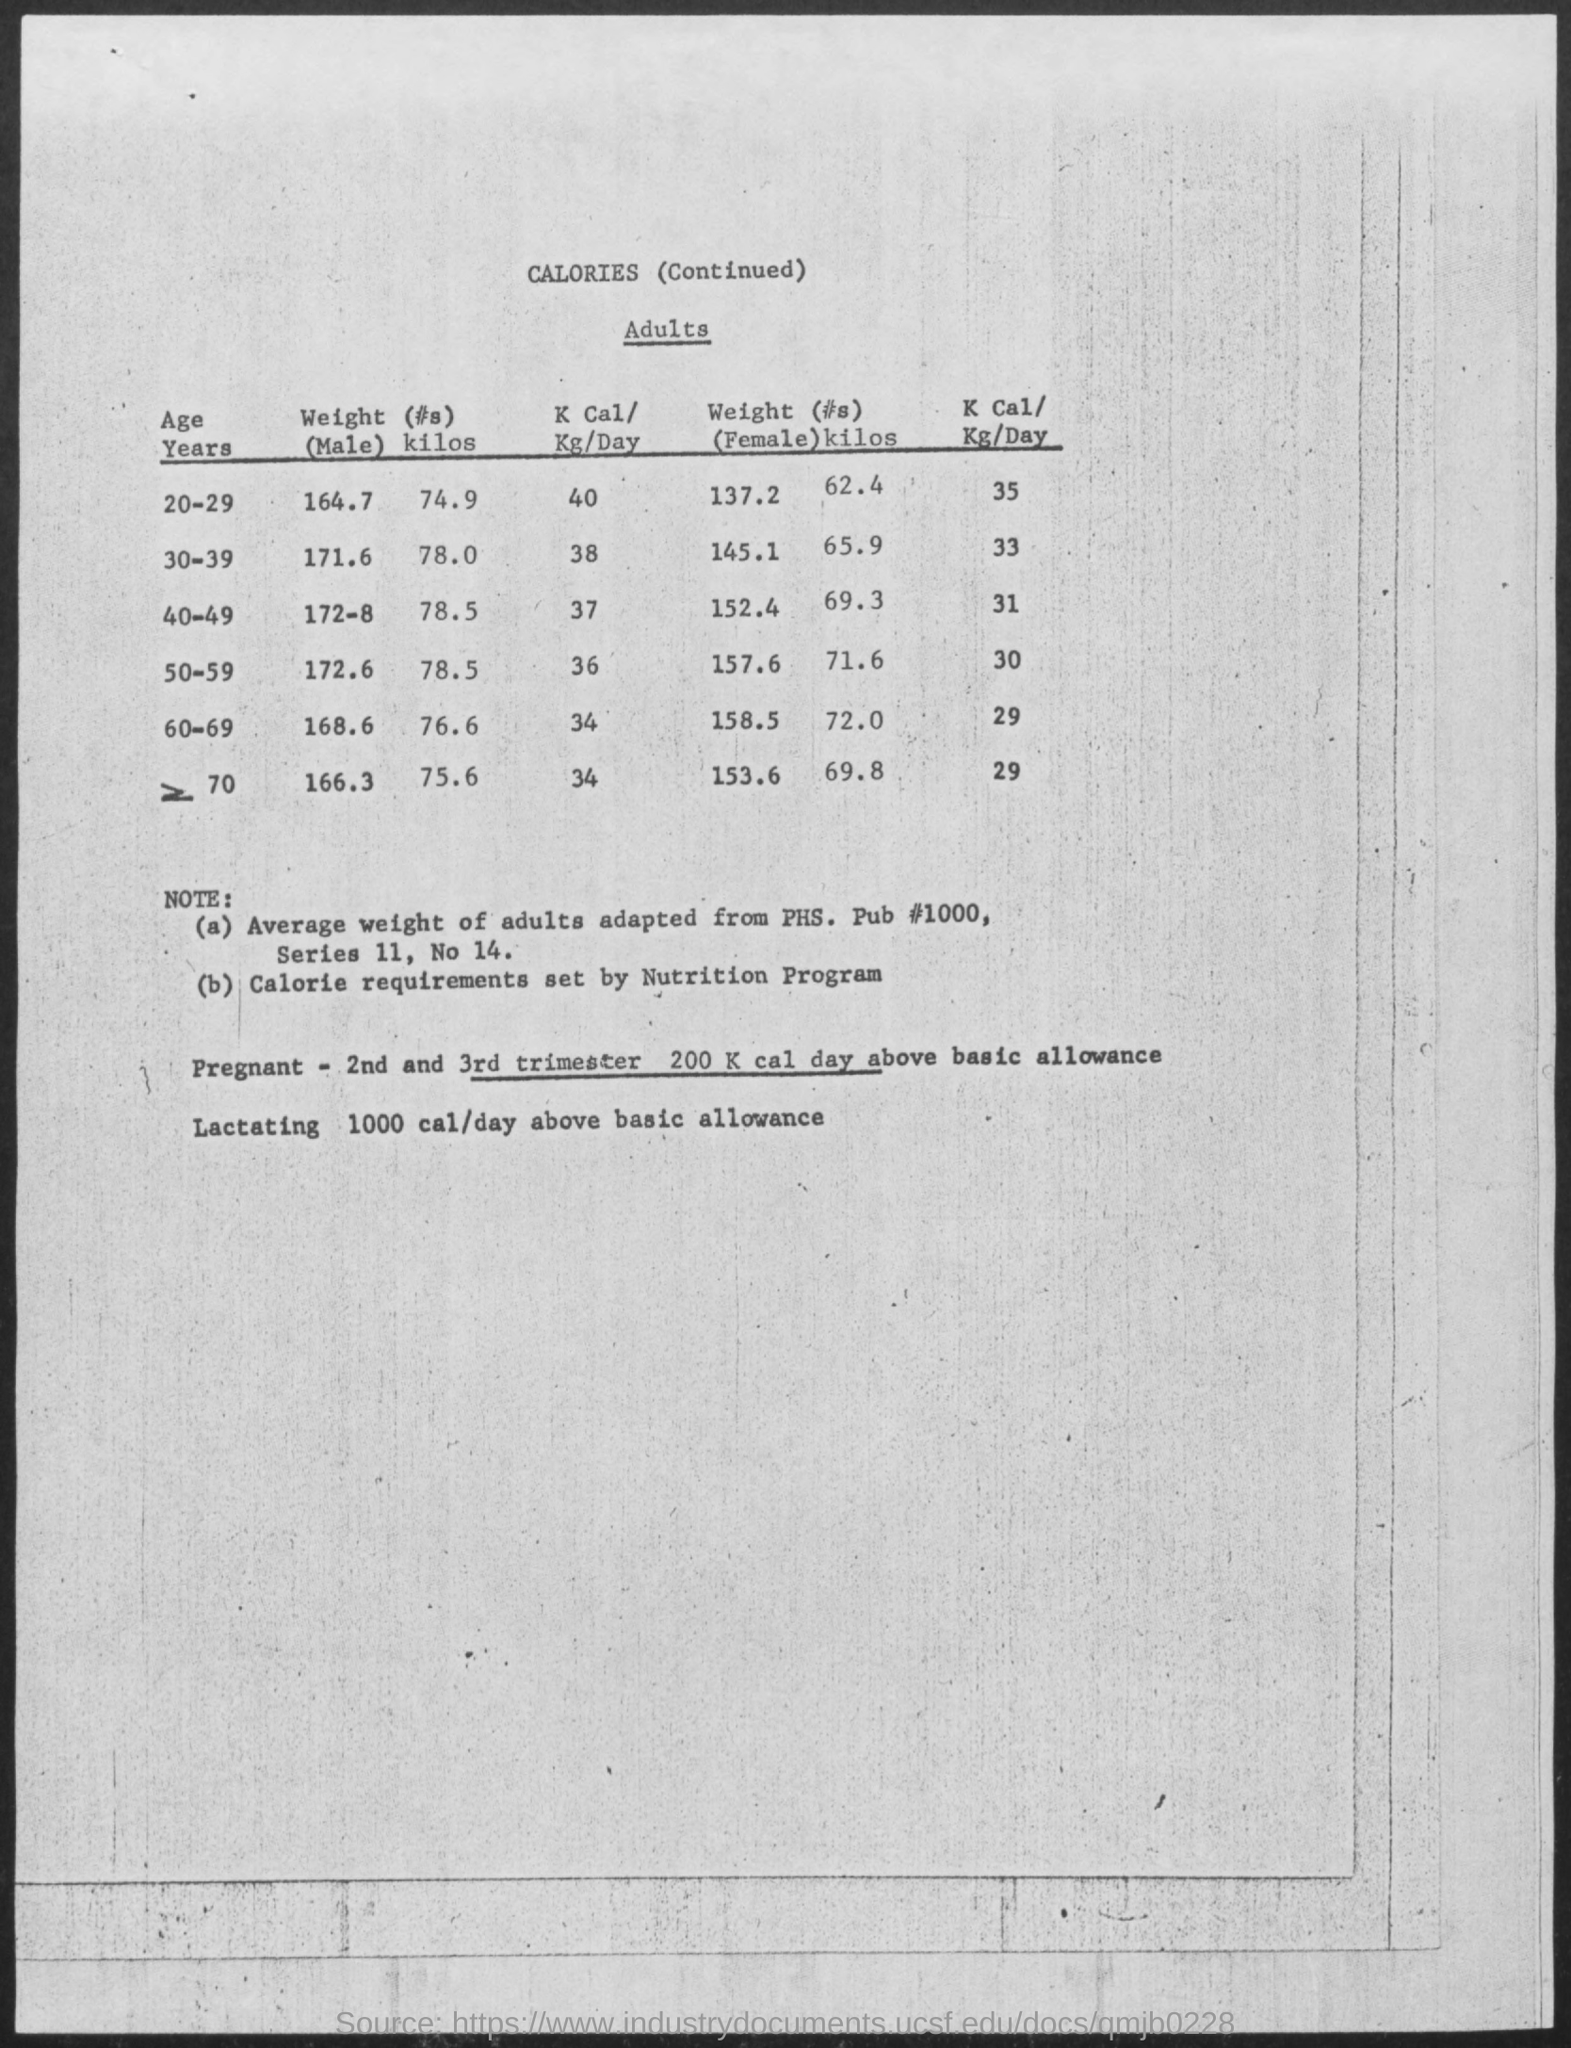What is the Weight for Male of Age 20-29?
Your answer should be very brief. 164.7. What is the Weight for Male of Age 30-39?
Ensure brevity in your answer.  171.6. What is the Weight for Male of Age 40-49?
Your answer should be compact. 172-8. What is the Weight for Male of Age 50-59?
Ensure brevity in your answer.  172.6. What is the Weight for Male of Age 60-69?
Make the answer very short. 168.6. What is the Weight for FeMale of Age 20-29?
Ensure brevity in your answer.  137.2. What is the Weight for FeMale of Age 30-39?
Ensure brevity in your answer.  145.1. What is the Weight for FeMale of Age 40-49?
Provide a short and direct response. 152.4. What is the Weight for FeMale of Age 50-59?
Offer a very short reply. 157.6. What is the Weight for FeMale of Age 60-69?
Make the answer very short. 158.5. 